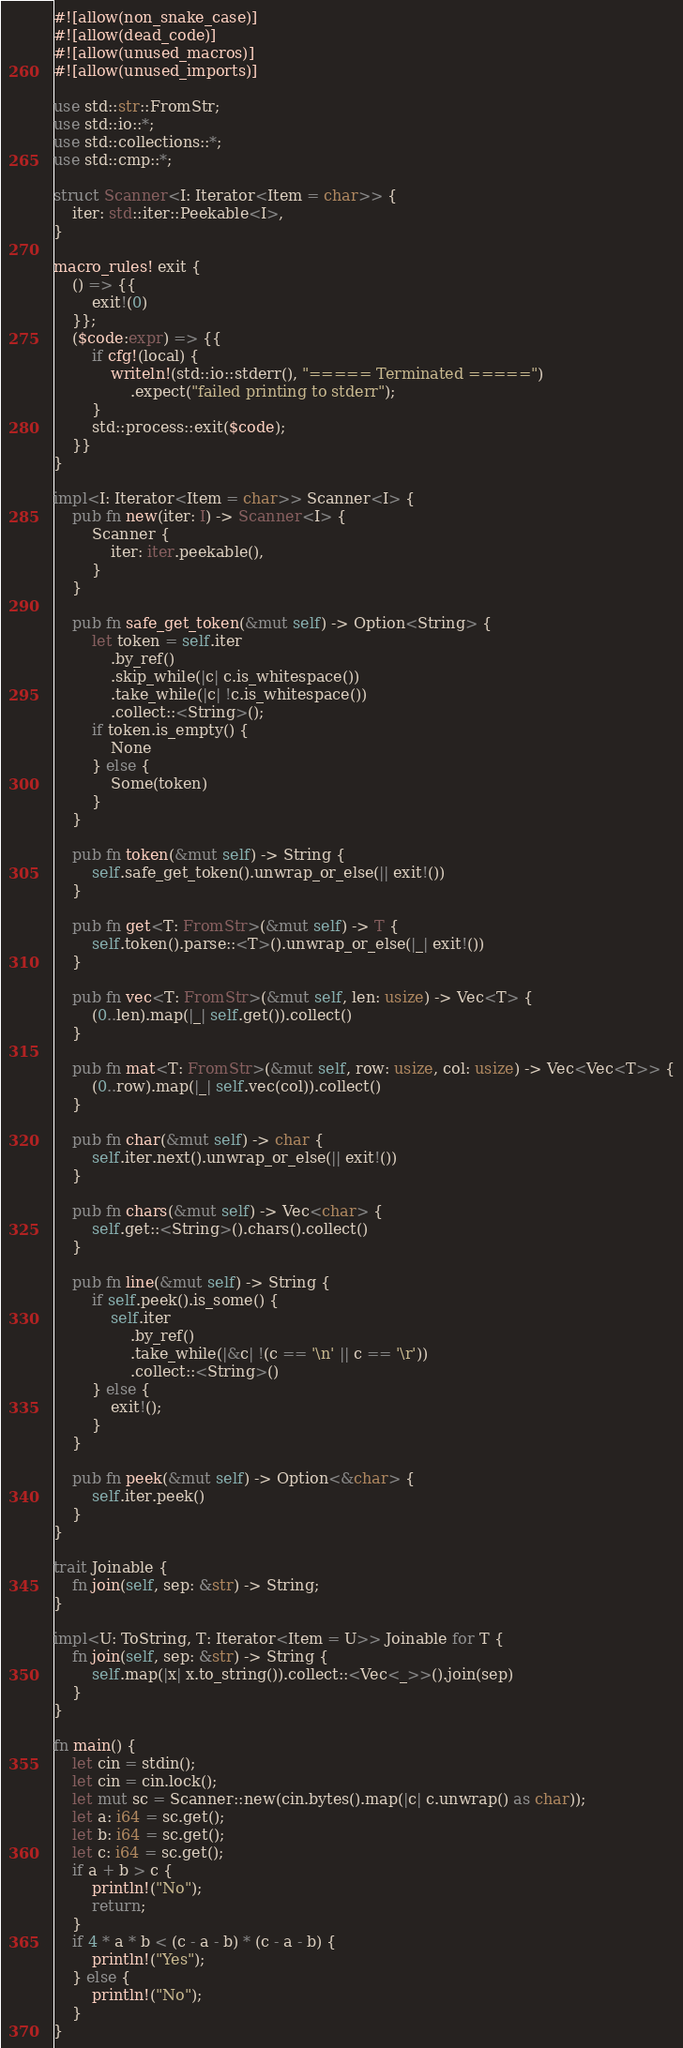Convert code to text. <code><loc_0><loc_0><loc_500><loc_500><_Rust_>#![allow(non_snake_case)]
#![allow(dead_code)]
#![allow(unused_macros)]
#![allow(unused_imports)]

use std::str::FromStr;
use std::io::*;
use std::collections::*;
use std::cmp::*;

struct Scanner<I: Iterator<Item = char>> {
    iter: std::iter::Peekable<I>,
}

macro_rules! exit {
    () => {{
        exit!(0)
    }};
    ($code:expr) => {{
        if cfg!(local) {
            writeln!(std::io::stderr(), "===== Terminated =====")
                .expect("failed printing to stderr");
        }
        std::process::exit($code);
    }}
}

impl<I: Iterator<Item = char>> Scanner<I> {
    pub fn new(iter: I) -> Scanner<I> {
        Scanner {
            iter: iter.peekable(),
        }
    }

    pub fn safe_get_token(&mut self) -> Option<String> {
        let token = self.iter
            .by_ref()
            .skip_while(|c| c.is_whitespace())
            .take_while(|c| !c.is_whitespace())
            .collect::<String>();
        if token.is_empty() {
            None
        } else {
            Some(token)
        }
    }

    pub fn token(&mut self) -> String {
        self.safe_get_token().unwrap_or_else(|| exit!())
    }

    pub fn get<T: FromStr>(&mut self) -> T {
        self.token().parse::<T>().unwrap_or_else(|_| exit!())
    }

    pub fn vec<T: FromStr>(&mut self, len: usize) -> Vec<T> {
        (0..len).map(|_| self.get()).collect()
    }

    pub fn mat<T: FromStr>(&mut self, row: usize, col: usize) -> Vec<Vec<T>> {
        (0..row).map(|_| self.vec(col)).collect()
    }

    pub fn char(&mut self) -> char {
        self.iter.next().unwrap_or_else(|| exit!())
    }

    pub fn chars(&mut self) -> Vec<char> {
        self.get::<String>().chars().collect()
    }

    pub fn line(&mut self) -> String {
        if self.peek().is_some() {
            self.iter
                .by_ref()
                .take_while(|&c| !(c == '\n' || c == '\r'))
                .collect::<String>()
        } else {
            exit!();
        }
    }

    pub fn peek(&mut self) -> Option<&char> {
        self.iter.peek()
    }
}

trait Joinable {
    fn join(self, sep: &str) -> String;
}

impl<U: ToString, T: Iterator<Item = U>> Joinable for T {
    fn join(self, sep: &str) -> String {
        self.map(|x| x.to_string()).collect::<Vec<_>>().join(sep)
    }
}

fn main() {
    let cin = stdin();
    let cin = cin.lock();
    let mut sc = Scanner::new(cin.bytes().map(|c| c.unwrap() as char));
    let a: i64 = sc.get();
    let b: i64 = sc.get();
    let c: i64 = sc.get();
    if a + b > c {
        println!("No");
        return;
    }
    if 4 * a * b < (c - a - b) * (c - a - b) {
        println!("Yes");
    } else {
        println!("No");
    }
}
</code> 